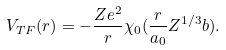Convert formula to latex. <formula><loc_0><loc_0><loc_500><loc_500>V _ { T F } ( r ) = - \frac { Z e ^ { 2 } } { r } \chi _ { 0 } ( \frac { r } { a _ { 0 } } Z ^ { 1 / 3 } b ) .</formula> 